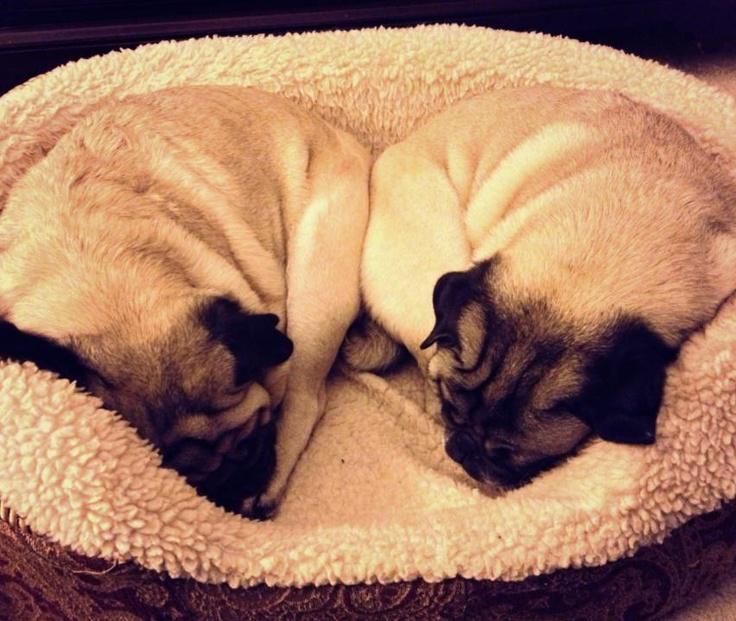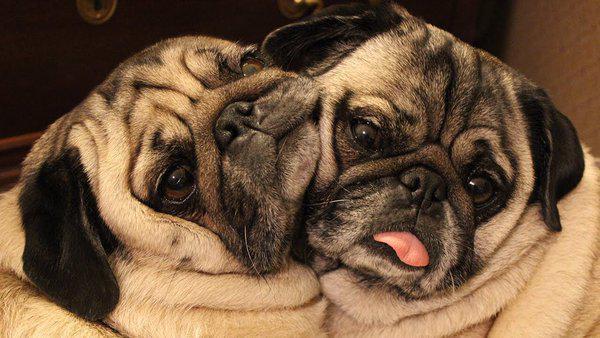The first image is the image on the left, the second image is the image on the right. Examine the images to the left and right. Is the description "Two camel-colored pugs relax together on a soft surface, with one posed above the other one." accurate? Answer yes or no. No. The first image is the image on the left, the second image is the image on the right. Given the left and right images, does the statement "The left image contains one black dog laying next to one tan dog." hold true? Answer yes or no. No. 